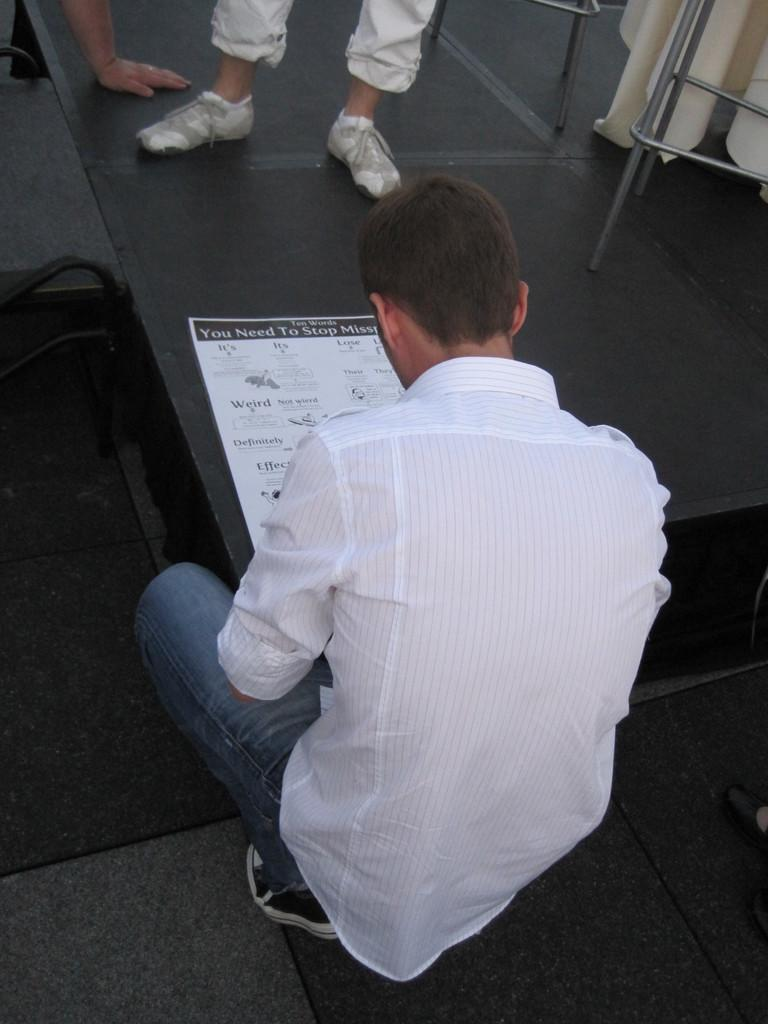What is the person sitting beside in the image? The person is sitting beside a bench in the image. What can be seen on the bench? There is a paper visible on the bench. How many people are in the image? There are two people in the image. What is located at the back of the image? There is a stand at the back in the image. What type of paste is being used by the person sitting beside the bench in the image? There is no indication of any paste being used in the image. 